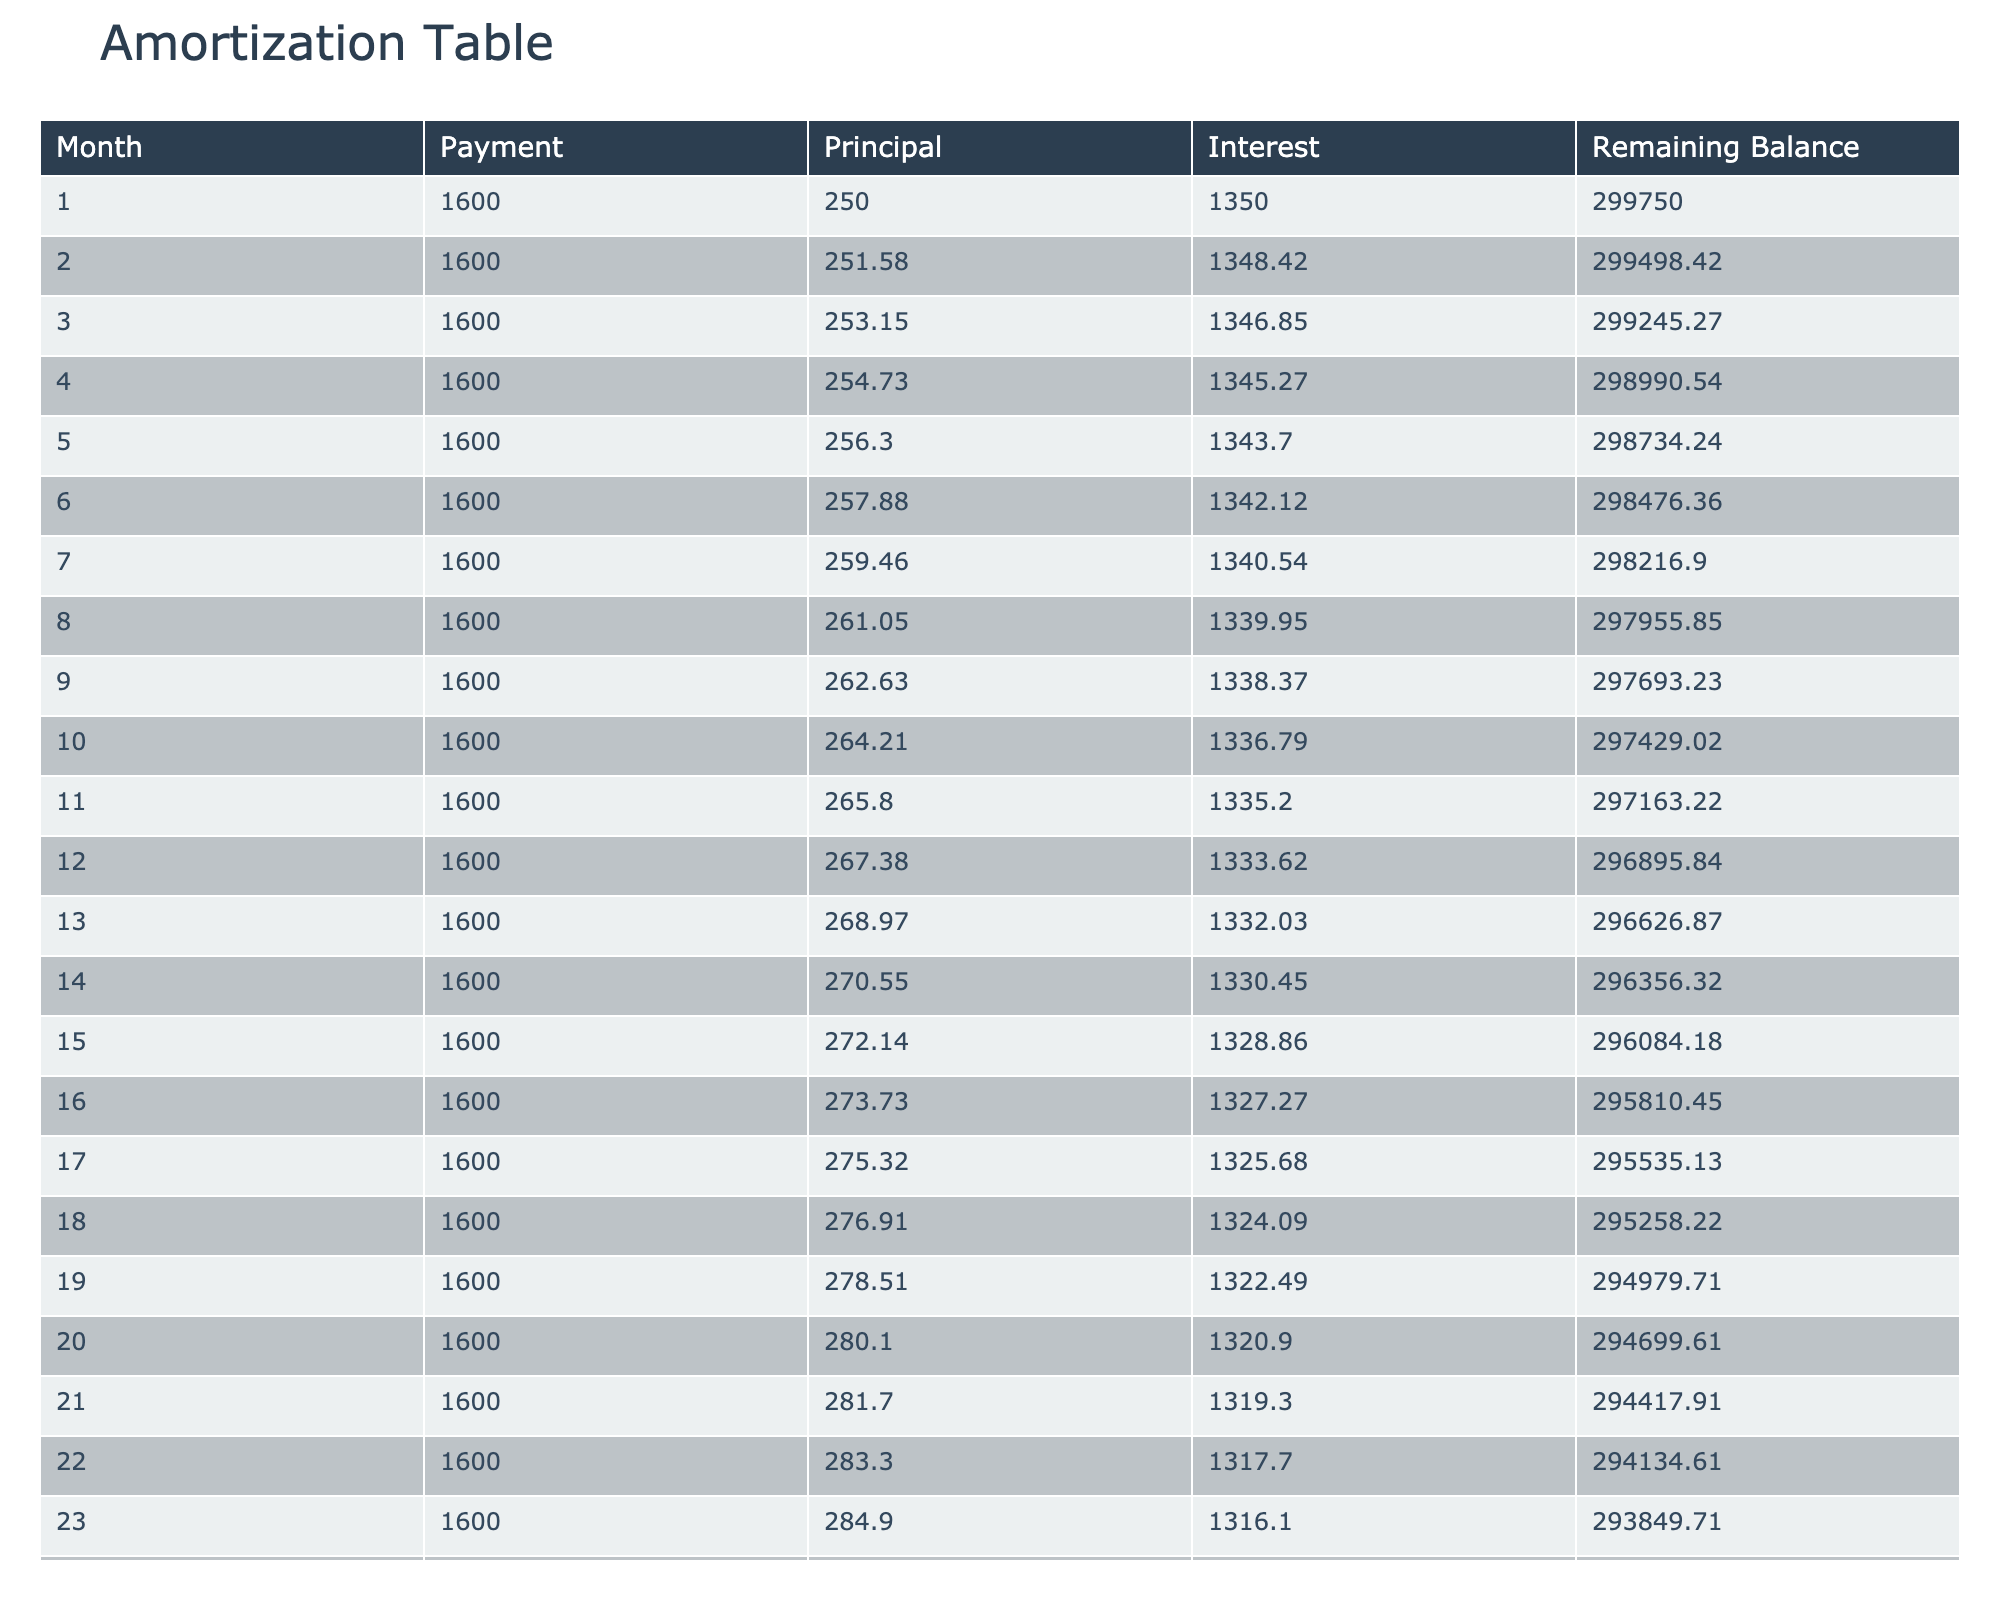What was the payment amount in the first month? The first month’s payment is listed directly in the table under the 'Payment' column for Month 1, which is 1600.00.
Answer: 1600.00 How much of the payment in the second month went towards principal? The table shows that in the second month, the 'Principal' amount for Month 2 is 251.58.
Answer: 251.58 What is the remaining balance after 10 months? After checking the table, the 'Remaining Balance' for Month 10 is listed as 297429.02.
Answer: 297429.02 Is the interest payment increasing or decreasing over the first few months? By comparing the 'Interest' values for the first few months, we see 1350.00 in Month 1 and it decreases gradually down to 1336.79 in Month 10. This indicates a decreasing trend.
Answer: Decreasing What is the total principal paid off by the end of the first year (12 months)? We need to sum the 'Principal' amounts from Month 1 to Month 12. Adding these values gives us a total of (250 + 251.58 + 253.15 + 254.73 + 256.30 + 257.88 + 259.46 + 261.05 + 262.63 + 264.21 + 265.80 + 267.38) = 3,045.94.
Answer: 3045.94 What was the monthly change in interest payment from Month 5 to Month 6? The interest in Month 5 is 1343.70, while in Month 6 it is 1342.12. The change in interest is 1342.12 - 1343.70 = -1.58, indicating a slight decrease.
Answer: -1.58 By how much does the remaining balance reduce from Month 20 to Month 21? The remaining balance in Month 20 is 294699.61 and in Month 21 it is 294417.91. The decrease in the remaining balance is 294699.61 - 294417.91 = 281.70.
Answer: 281.70 Is the total interest paid in the first 5 months higher than 6700? The total interest for the first 5 months is 1350.00 + 1348.42 + 1346.85 + 1345.27 + 1343.70 = 6740.24, which is indeed higher than 6700.
Answer: Yes What is the average principal payment over the first 15 months? To find the average, we need to sum the principal payments for the first 15 months, which gives us (250 + 251.58 + 253.15 + 254.73 + 256.30 + 257.88 + 259.46 + 261.05 + 262.63 + 264.21 + 265.80 + 267.38 + 268.97 + 270.55 + 272.14) = 3,923.89. The average is then 3923.89 / 15 = 261.59.
Answer: 261.59 